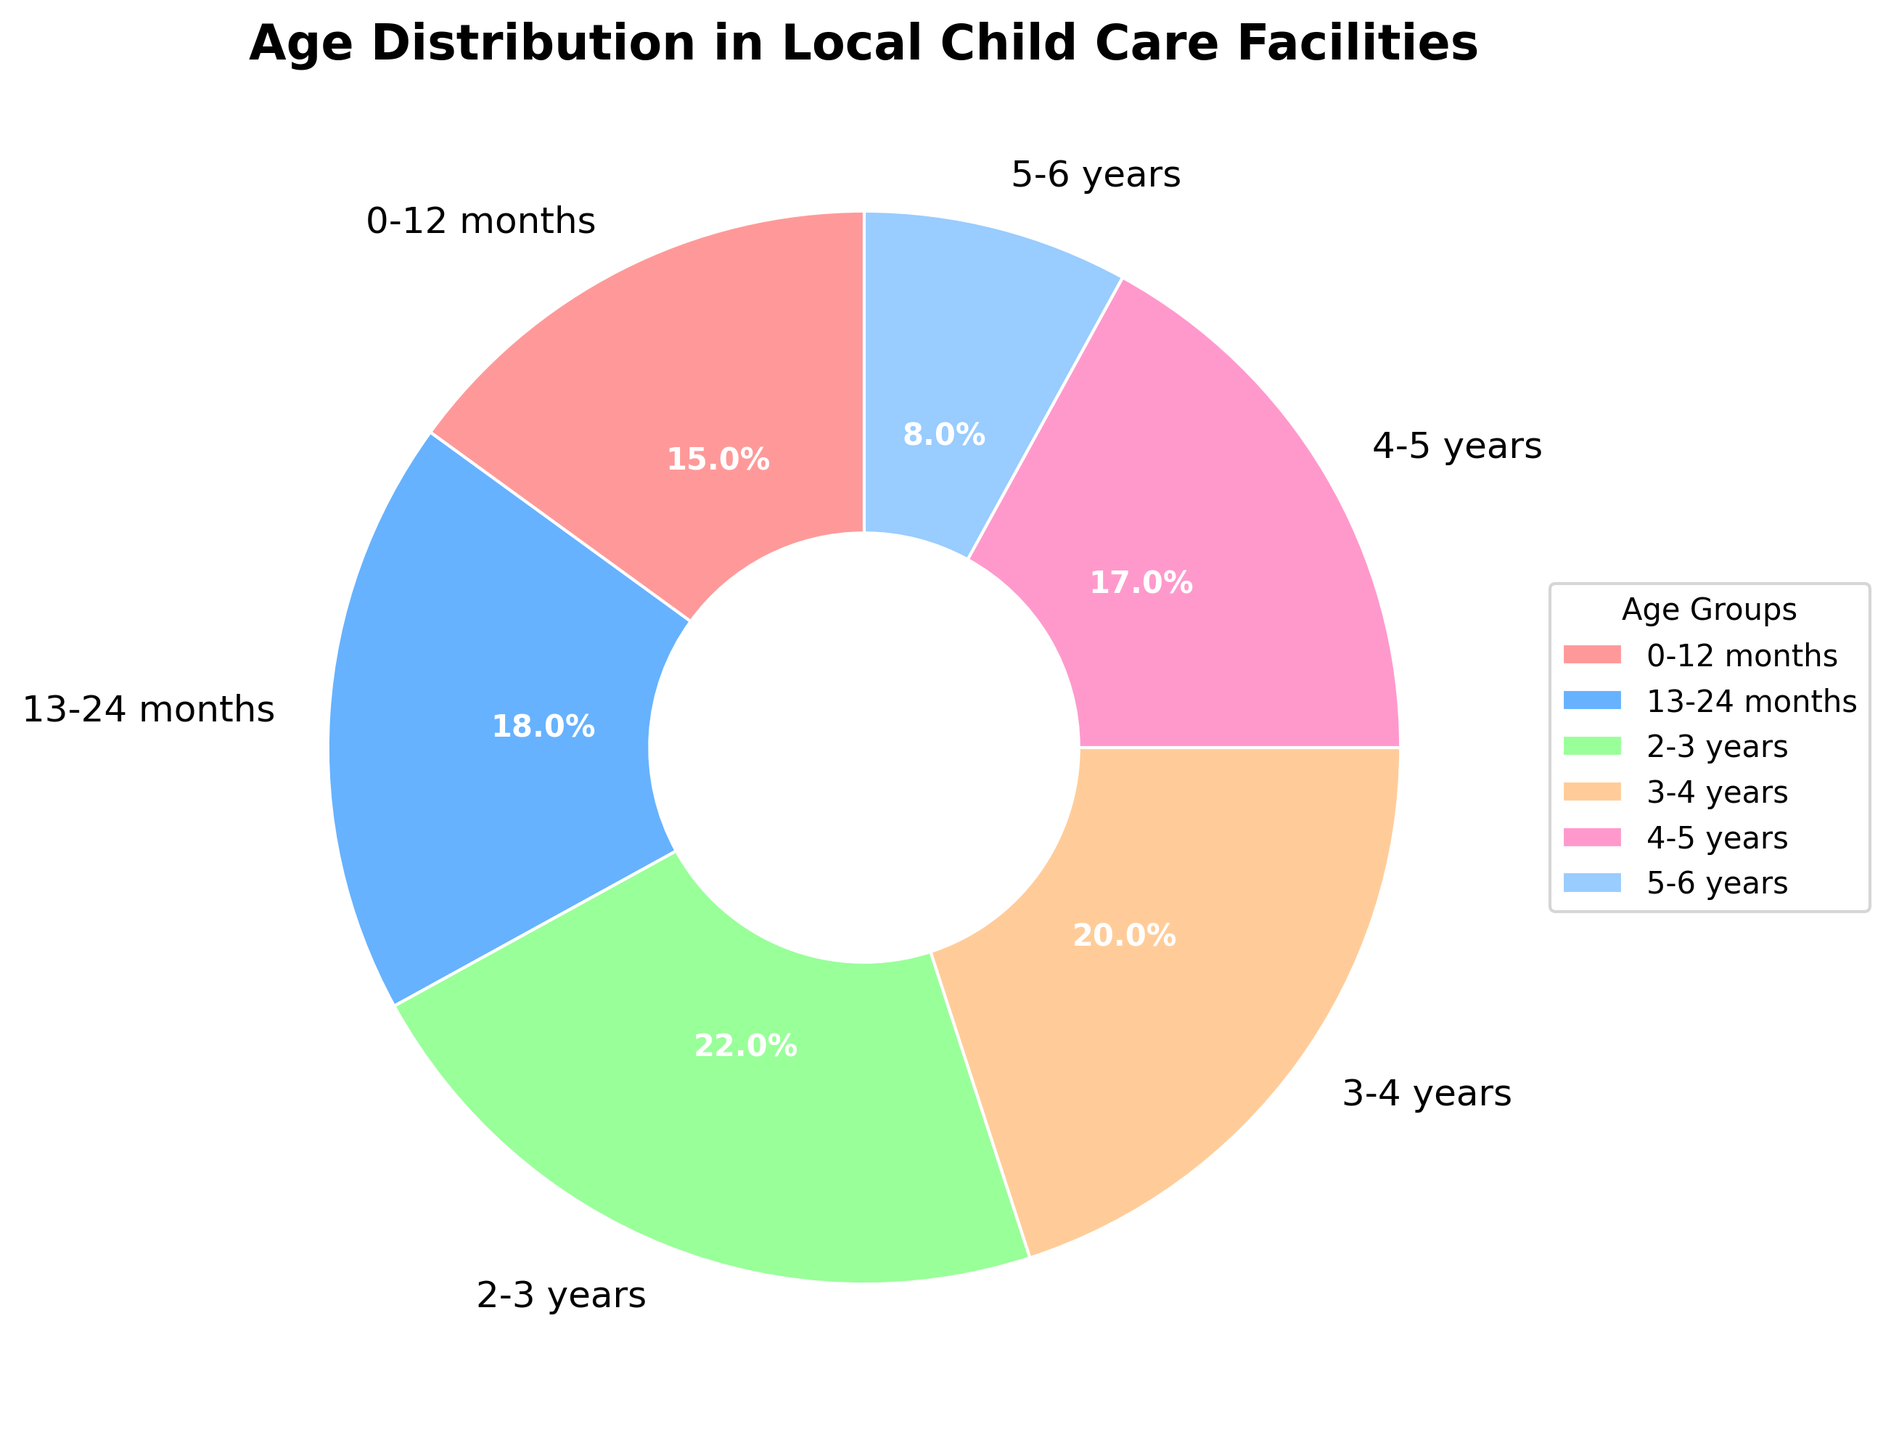What is the most common age group of children in local child care facilities? The most common age group is the one with the highest percentage shown in the pie chart. In this case, "2-3 years" has the highest percentage.
Answer: 2-3 years Which age group has the least representation? The least represented age group is shown as the slice with the smallest percentage in the pie chart, which is "5-6 years" with 8%.
Answer: 5-6 years What is the combined percentage of children aged 0-12 months and 13-24 months? Add the percentages for the "0-12 months" (15%) and "13-24 months" (18%) age groups: 15 + 18 = 33%.
Answer: 33% Compare the percentages of the 3-4 years and 4-5 years age groups: Which is higher and by how much? The "3-4 years" group is higher (20%) compared to the "4-5 years" group (17%). The difference is 20 - 17 = 3%.
Answer: 3-4 years by 3% What is the combined percentage of children aged 2-3 years and older groups (3-4 years, 4-5 years, 5-6 years)? Add the percentages for "2-3 years" (22%), "3-4 years" (20%), "4-5 years" (17%), and "5-6 years" (8%): 22 + 20 + 17 + 8 = 67%.
Answer: 67% Which age groups have a percentage greater than 20%? The age groups with percentages greater than 20% are shown as slices more than one-fifth of the pie. The age groups are "2-3 years" (22%) and "3-4 years" (20%).
Answer: 2-3 years, 3-4 years What is the difference in percentage between the youngest age group (0-12 months) and the oldest age group (5-6 years)? Subtract the percentage of the "5-6 years" group (8%) from the "0-12 months" group (15%): 15 - 8 = 7%.
Answer: 7% What color represents the 13-24 months age group in the chart? The 13-24 months age group is represented by the second color in the legend, which is blue.
Answer: Blue Which two age groups together account for the largest combined percentage of children? Add up pairs of age groups and find the maximum combined percentage. "2-3 years" (22%) and "3-4 years" (20%) together have the largest combined percentage: 22 + 20 = 42%.
Answer: 2-3 years, 3-4 years 